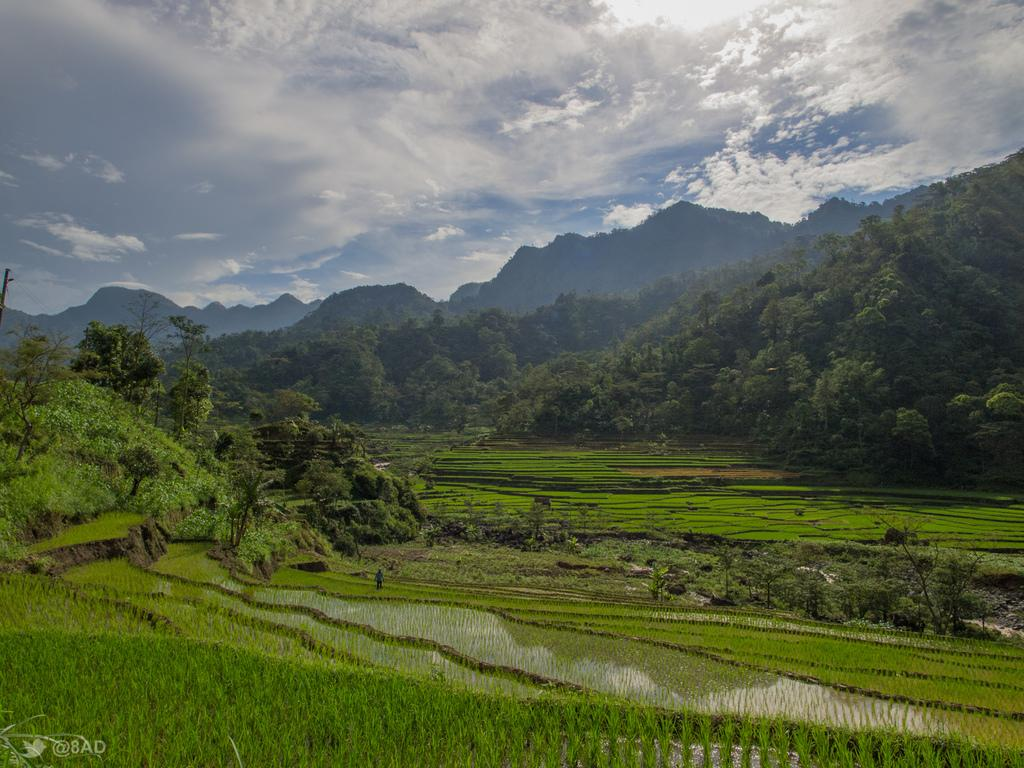What type of vegetation can be seen in the image? There is grass in the image. What is visible on the surface in the image? There is water visible on the surface in the image. What can be seen in the background of the image? There are trees and mountains in the background of the image. What is visible in the sky at the top of the image? There are clouds visible in the sky at the top of the image. How many balls are visible in the image? There are no balls present in the image. What is the chance of winning a prize in the image? There is no game or prize-winning activity depicted in the image. 